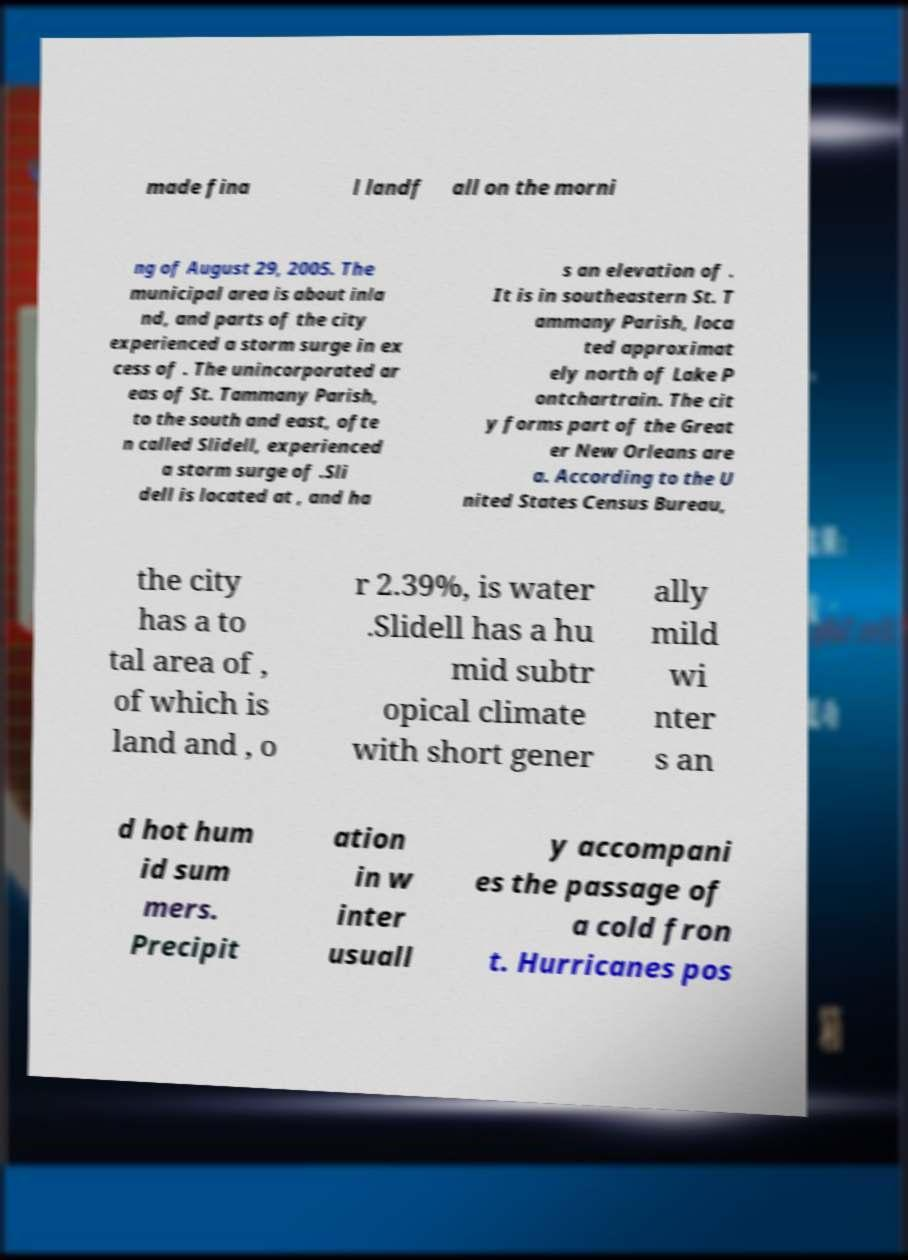For documentation purposes, I need the text within this image transcribed. Could you provide that? made fina l landf all on the morni ng of August 29, 2005. The municipal area is about inla nd, and parts of the city experienced a storm surge in ex cess of . The unincorporated ar eas of St. Tammany Parish, to the south and east, ofte n called Slidell, experienced a storm surge of .Sli dell is located at , and ha s an elevation of . It is in southeastern St. T ammany Parish, loca ted approximat ely north of Lake P ontchartrain. The cit y forms part of the Great er New Orleans are a. According to the U nited States Census Bureau, the city has a to tal area of , of which is land and , o r 2.39%, is water .Slidell has a hu mid subtr opical climate with short gener ally mild wi nter s an d hot hum id sum mers. Precipit ation in w inter usuall y accompani es the passage of a cold fron t. Hurricanes pos 